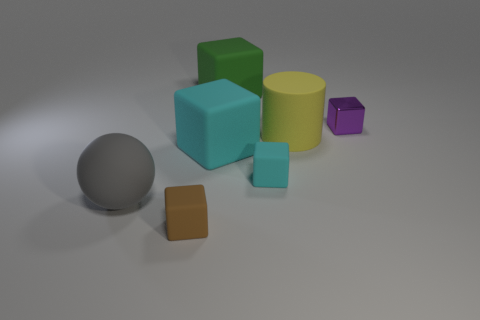What number of other objects are the same size as the purple metallic thing?
Give a very brief answer. 2. There is a rubber thing left of the tiny rubber cube left of the large cyan thing; is there a cylinder that is in front of it?
Make the answer very short. No. What size is the brown thing?
Keep it short and to the point. Small. What size is the object on the right side of the yellow thing?
Provide a succinct answer. Small. There is a gray rubber sphere on the left side of the green object; is it the same size as the big cyan matte thing?
Offer a very short reply. Yes. Are there any other things that are the same color as the big rubber ball?
Provide a short and direct response. No. There is a gray rubber thing; what shape is it?
Your answer should be very brief. Sphere. How many large rubber objects are both in front of the yellow object and to the right of the large green cube?
Provide a short and direct response. 0. Is the color of the large matte ball the same as the metal thing?
Provide a short and direct response. No. What material is the other tiny brown object that is the same shape as the small metallic thing?
Offer a terse response. Rubber. 